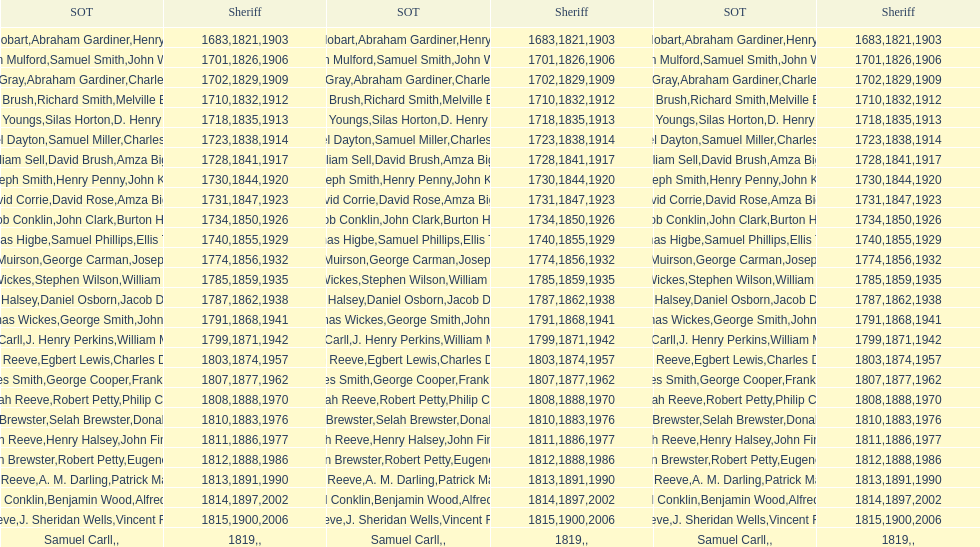How sheriffs has suffolk county had in total? 76. 